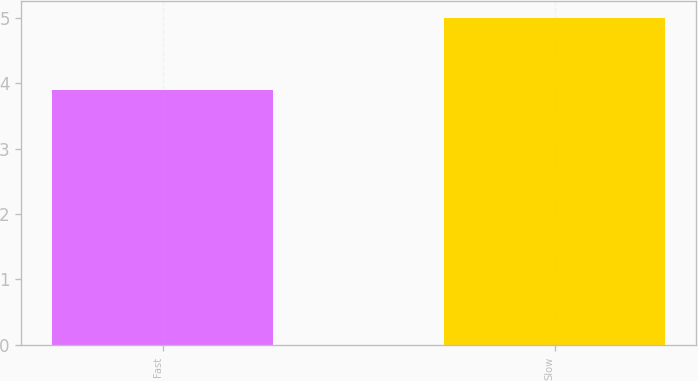<chart> <loc_0><loc_0><loc_500><loc_500><bar_chart><fcel>Fast<fcel>Slow<nl><fcel>3.9<fcel>5<nl></chart> 